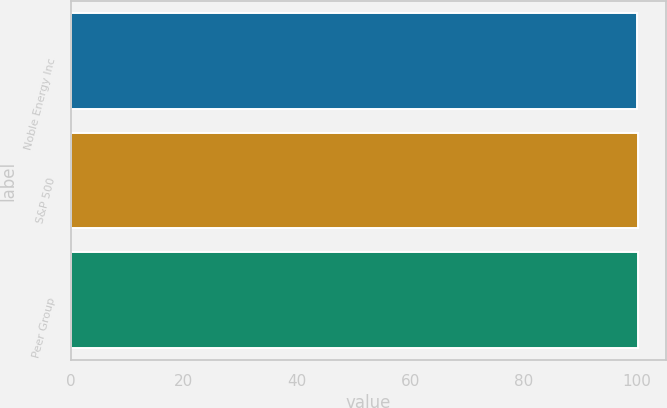<chart> <loc_0><loc_0><loc_500><loc_500><bar_chart><fcel>Noble Energy Inc<fcel>S&P 500<fcel>Peer Group<nl><fcel>100<fcel>100.1<fcel>100.2<nl></chart> 